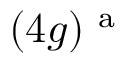Convert formula to latex. <formula><loc_0><loc_0><loc_500><loc_500>( 4 g ) ^ { a }</formula> 